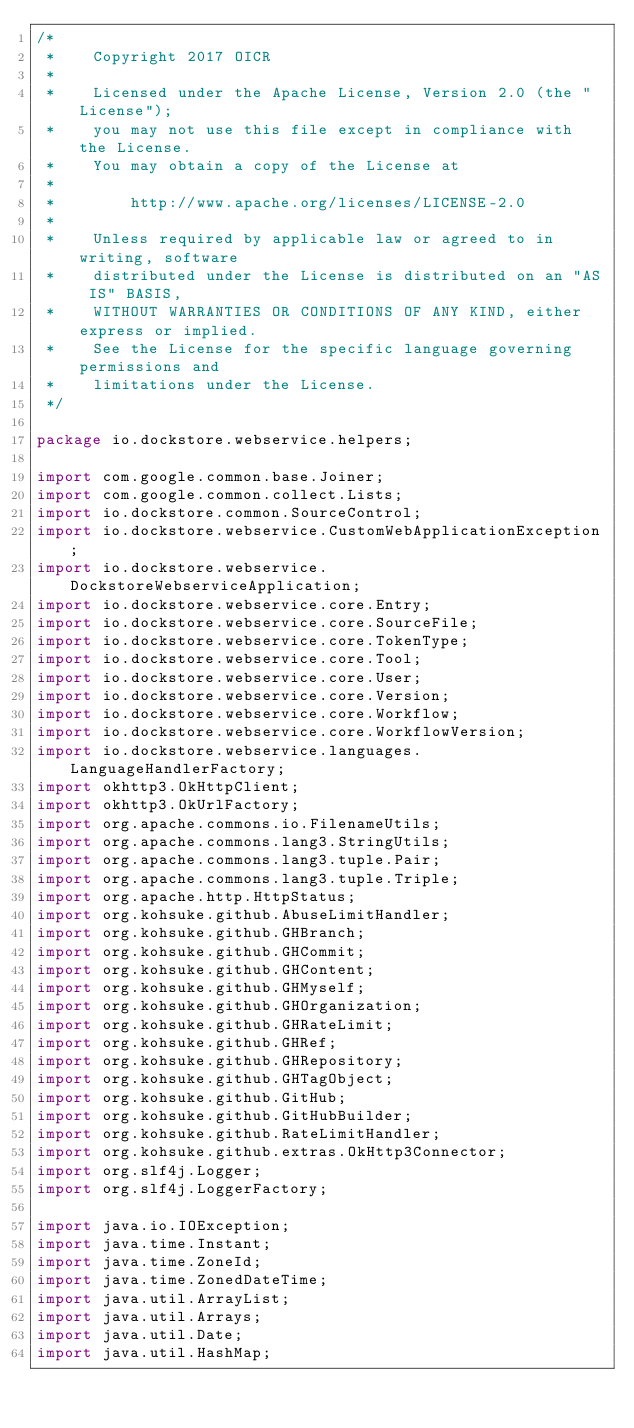Convert code to text. <code><loc_0><loc_0><loc_500><loc_500><_Java_>/*
 *    Copyright 2017 OICR
 *
 *    Licensed under the Apache License, Version 2.0 (the "License");
 *    you may not use this file except in compliance with the License.
 *    You may obtain a copy of the License at
 *
 *        http://www.apache.org/licenses/LICENSE-2.0
 *
 *    Unless required by applicable law or agreed to in writing, software
 *    distributed under the License is distributed on an "AS IS" BASIS,
 *    WITHOUT WARRANTIES OR CONDITIONS OF ANY KIND, either express or implied.
 *    See the License for the specific language governing permissions and
 *    limitations under the License.
 */

package io.dockstore.webservice.helpers;

import com.google.common.base.Joiner;
import com.google.common.collect.Lists;
import io.dockstore.common.SourceControl;
import io.dockstore.webservice.CustomWebApplicationException;
import io.dockstore.webservice.DockstoreWebserviceApplication;
import io.dockstore.webservice.core.Entry;
import io.dockstore.webservice.core.SourceFile;
import io.dockstore.webservice.core.TokenType;
import io.dockstore.webservice.core.Tool;
import io.dockstore.webservice.core.User;
import io.dockstore.webservice.core.Version;
import io.dockstore.webservice.core.Workflow;
import io.dockstore.webservice.core.WorkflowVersion;
import io.dockstore.webservice.languages.LanguageHandlerFactory;
import okhttp3.OkHttpClient;
import okhttp3.OkUrlFactory;
import org.apache.commons.io.FilenameUtils;
import org.apache.commons.lang3.StringUtils;
import org.apache.commons.lang3.tuple.Pair;
import org.apache.commons.lang3.tuple.Triple;
import org.apache.http.HttpStatus;
import org.kohsuke.github.AbuseLimitHandler;
import org.kohsuke.github.GHBranch;
import org.kohsuke.github.GHCommit;
import org.kohsuke.github.GHContent;
import org.kohsuke.github.GHMyself;
import org.kohsuke.github.GHOrganization;
import org.kohsuke.github.GHRateLimit;
import org.kohsuke.github.GHRef;
import org.kohsuke.github.GHRepository;
import org.kohsuke.github.GHTagObject;
import org.kohsuke.github.GitHub;
import org.kohsuke.github.GitHubBuilder;
import org.kohsuke.github.RateLimitHandler;
import org.kohsuke.github.extras.OkHttp3Connector;
import org.slf4j.Logger;
import org.slf4j.LoggerFactory;

import java.io.IOException;
import java.time.Instant;
import java.time.ZoneId;
import java.time.ZonedDateTime;
import java.util.ArrayList;
import java.util.Arrays;
import java.util.Date;
import java.util.HashMap;</code> 